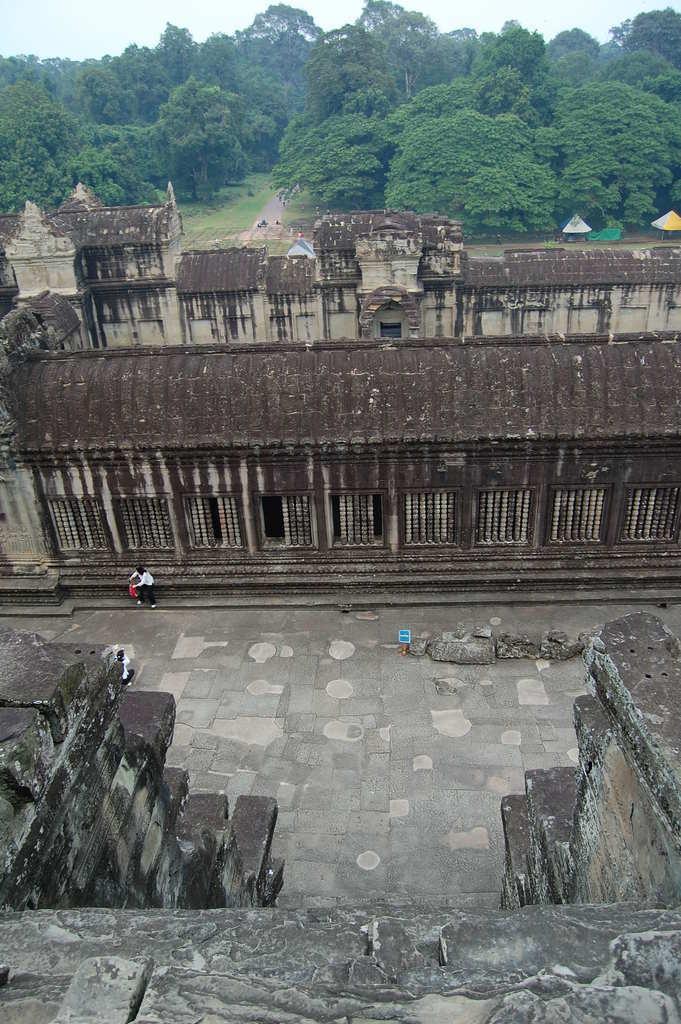How would you summarize this image in a sentence or two? There are people and we can see fort and rooftops. In the background we can see tents, trees, road and sky. 